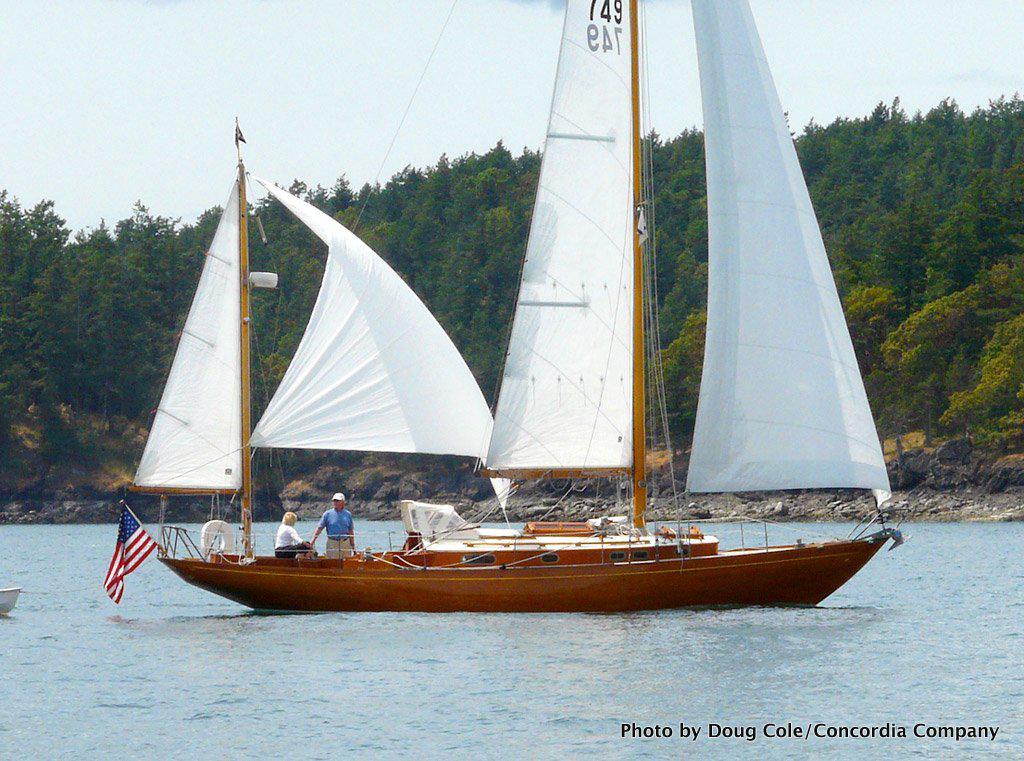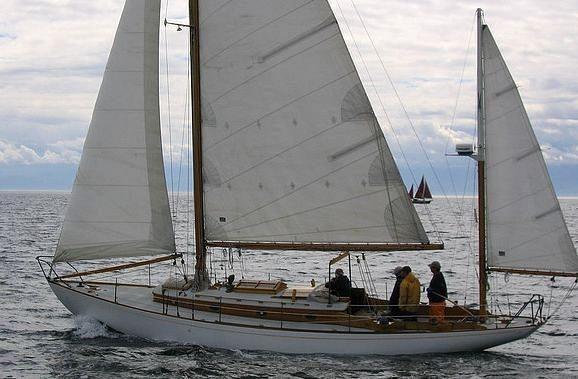The first image is the image on the left, the second image is the image on the right. Examine the images to the left and right. Is the description "The left and right image contains the same number of  sailboats in the water." accurate? Answer yes or no. Yes. The first image is the image on the left, the second image is the image on the right. For the images displayed, is the sentence "People are sailing." factually correct? Answer yes or no. Yes. 